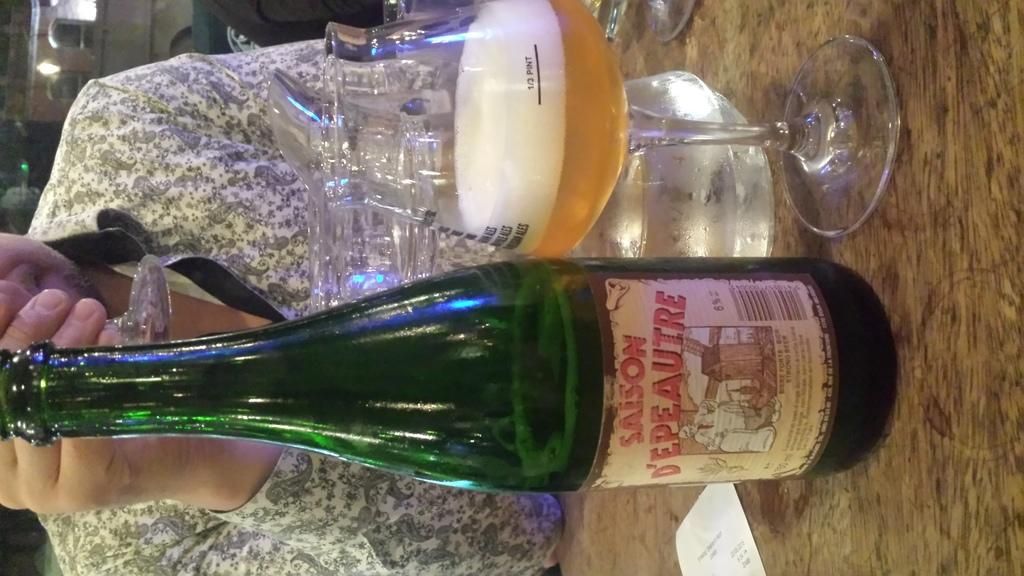<image>
Summarize the visual content of the image. the word Saison that is on a bottle 